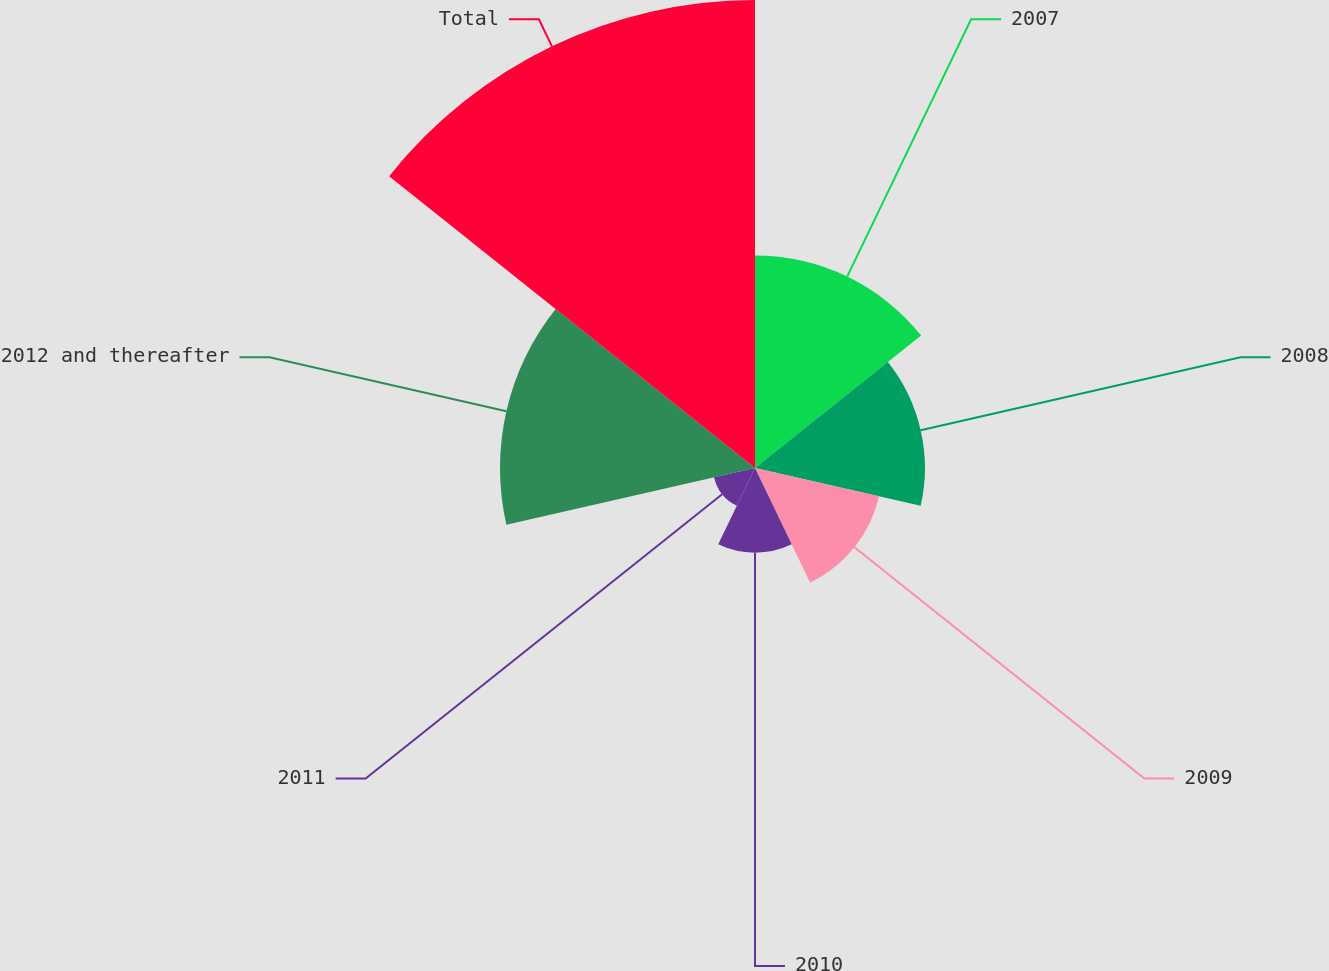<chart> <loc_0><loc_0><loc_500><loc_500><pie_chart><fcel>2007<fcel>2008<fcel>2009<fcel>2010<fcel>2011<fcel>2012 and thereafter<fcel>Total<nl><fcel>15.63%<fcel>12.5%<fcel>9.36%<fcel>6.23%<fcel>3.09%<fcel>18.76%<fcel>34.43%<nl></chart> 